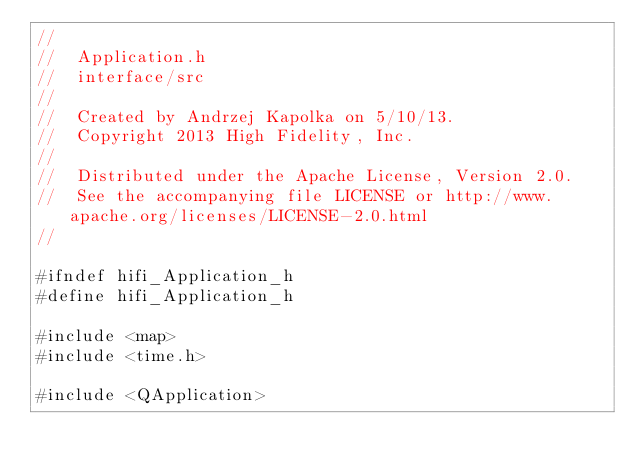Convert code to text. <code><loc_0><loc_0><loc_500><loc_500><_C_>//
//  Application.h
//  interface/src
//
//  Created by Andrzej Kapolka on 5/10/13.
//  Copyright 2013 High Fidelity, Inc.
//
//  Distributed under the Apache License, Version 2.0.
//  See the accompanying file LICENSE or http://www.apache.org/licenses/LICENSE-2.0.html
//

#ifndef hifi_Application_h
#define hifi_Application_h

#include <map>
#include <time.h>

#include <QApplication></code> 